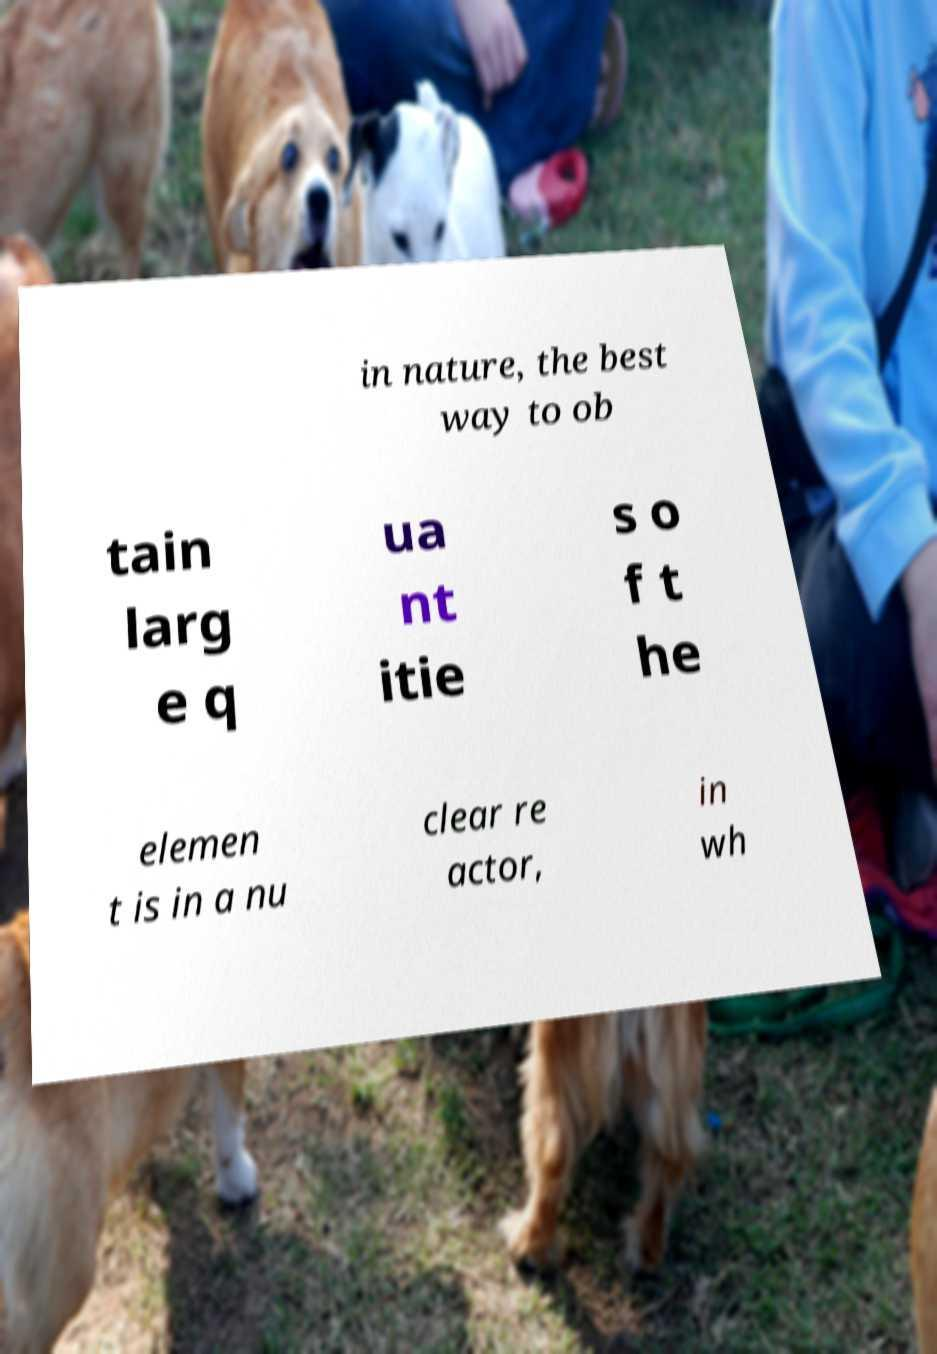Please identify and transcribe the text found in this image. in nature, the best way to ob tain larg e q ua nt itie s o f t he elemen t is in a nu clear re actor, in wh 